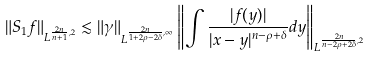<formula> <loc_0><loc_0><loc_500><loc_500>\| S _ { 1 } f \| _ { L ^ { \frac { 2 n } { n + 1 } , 2 } } \lesssim \| \gamma \| _ { L ^ { \frac { 2 n } { 1 + 2 \rho - 2 \delta } , \infty } } \left \| \int \frac { | f ( y ) | } { | x - y | ^ { n - \rho + \delta } } d y \right \| _ { L ^ { \frac { 2 n } { n - 2 \rho + 2 \delta } , 2 } }</formula> 